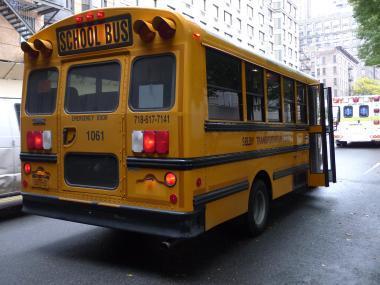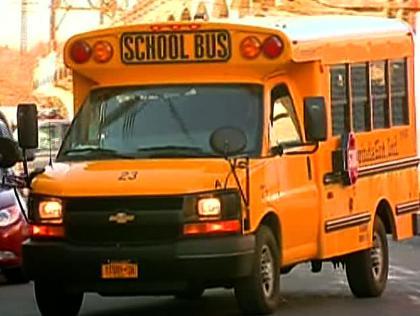The first image is the image on the left, the second image is the image on the right. Examine the images to the left and right. Is the description "One image shows a short leftward headed non-flat school bus with no more than five passenger windows per side, and the other image shows a short rightward angled bus from the rear." accurate? Answer yes or no. Yes. The first image is the image on the left, the second image is the image on the right. Analyze the images presented: Is the assertion "There are exactly two school buses." valid? Answer yes or no. Yes. 